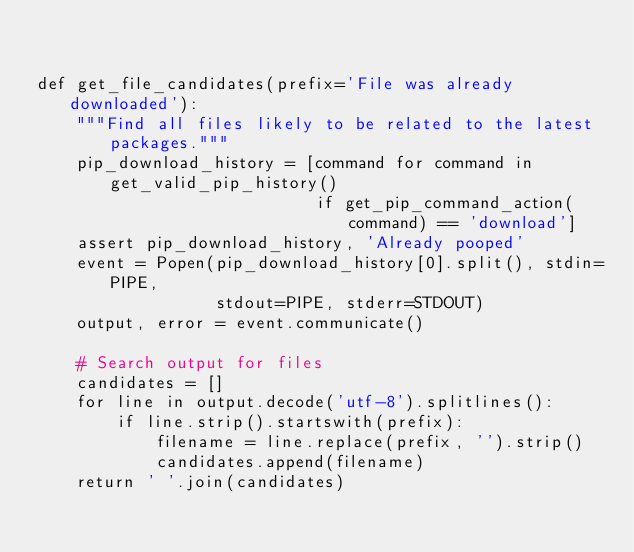Convert code to text. <code><loc_0><loc_0><loc_500><loc_500><_Python_>

def get_file_candidates(prefix='File was already downloaded'):
    """Find all files likely to be related to the latest packages."""
    pip_download_history = [command for command in get_valid_pip_history()
                            if get_pip_command_action(command) == 'download']
    assert pip_download_history, 'Already pooped'
    event = Popen(pip_download_history[0].split(), stdin=PIPE,
                  stdout=PIPE, stderr=STDOUT)
    output, error = event.communicate()

    # Search output for files
    candidates = []
    for line in output.decode('utf-8').splitlines():
        if line.strip().startswith(prefix):
            filename = line.replace(prefix, '').strip()
            candidates.append(filename)
    return ' '.join(candidates)
</code> 